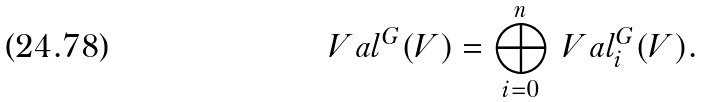Convert formula to latex. <formula><loc_0><loc_0><loc_500><loc_500>\ V a l ^ { G } ( V ) = \bigoplus _ { i = 0 } ^ { n } \ V a l ^ { G } _ { i } ( V ) .</formula> 